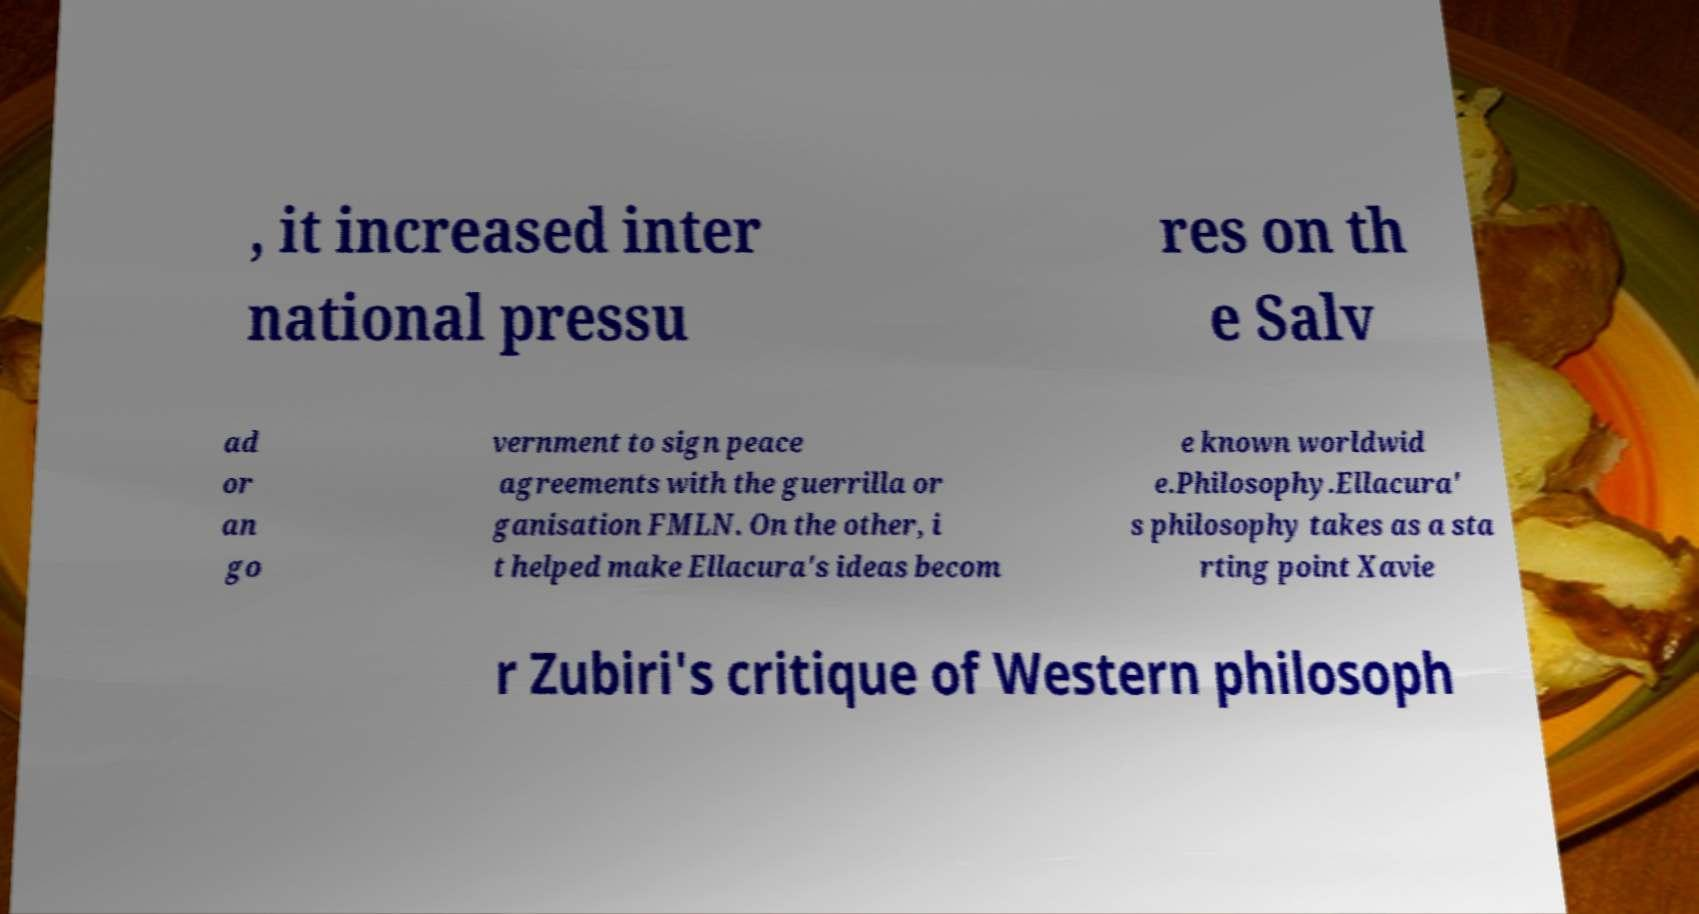Can you read and provide the text displayed in the image?This photo seems to have some interesting text. Can you extract and type it out for me? , it increased inter national pressu res on th e Salv ad or an go vernment to sign peace agreements with the guerrilla or ganisation FMLN. On the other, i t helped make Ellacura's ideas becom e known worldwid e.Philosophy.Ellacura' s philosophy takes as a sta rting point Xavie r Zubiri's critique of Western philosoph 